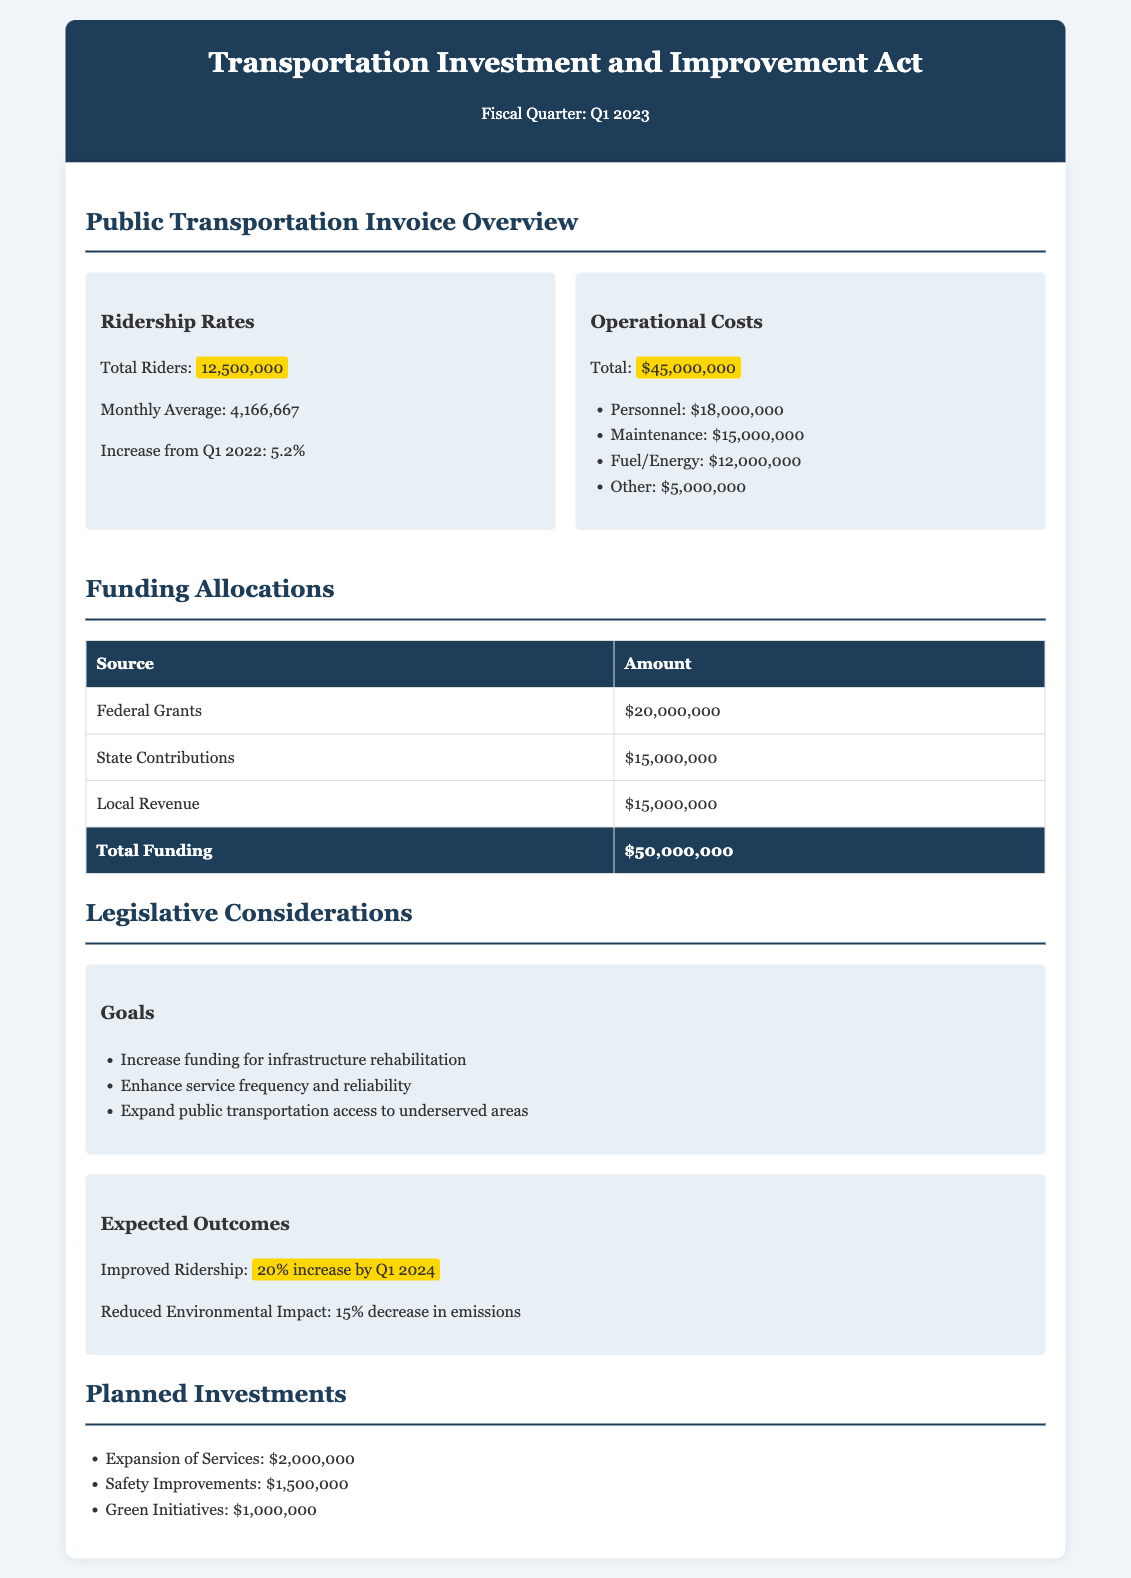What is the total number of riders in Q1 2023? The document states that the total number of riders is 12,500,000 for Q1 2023.
Answer: 12,500,000 What was the increase in ridership from Q1 2022? The document indicates that the increase in ridership from Q1 2022 was 5.2%.
Answer: 5.2% What are the operational costs for public transportation in Q1 2023? The total operational costs listed in the document is $45,000,000.
Answer: $45,000,000 What is the amount allocated from federal grants? The document specifies that federal grants contribute $20,000,000 towards funding.
Answer: $20,000,000 What is the total planned investment in green initiatives? The document outlines that the planned investment in green initiatives is $1,000,000.
Answer: $1,000,000 What is the goal related to service frequency mentioned in the document? The document states that one of the goals is to "Enhance service frequency and reliability."
Answer: Enhance service frequency and reliability What is the expected improvement in ridership by Q1 2024? According to the document, the expected improvement in ridership is a 20% increase by Q1 2024.
Answer: 20% increase by Q1 2024 How much funding is allocated from local revenue? The document lists the contribution from local revenue as $15,000,000.
Answer: $15,000,000 